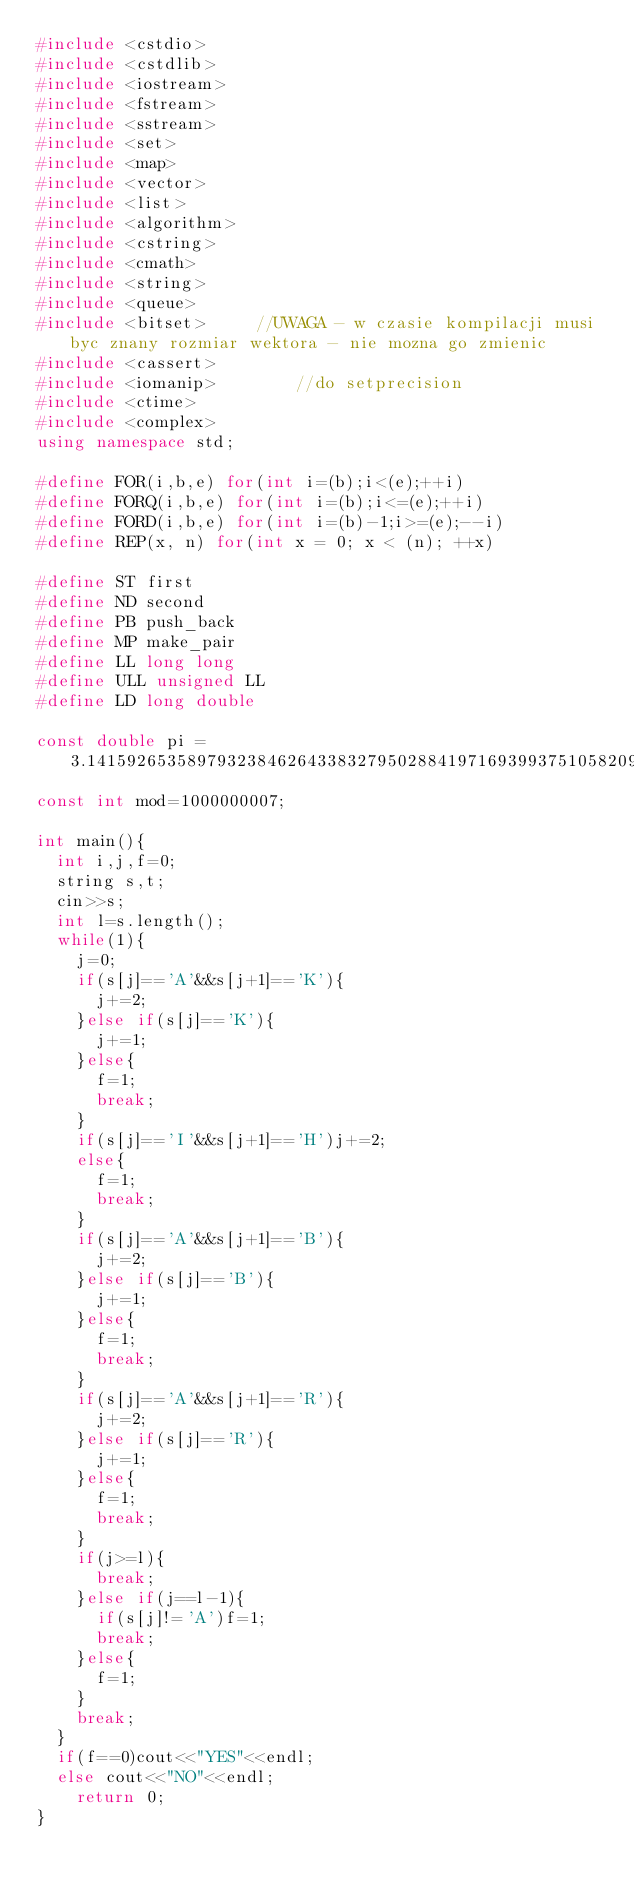Convert code to text. <code><loc_0><loc_0><loc_500><loc_500><_C++_>#include <cstdio>
#include <cstdlib>
#include <iostream>
#include <fstream>
#include <sstream>
#include <set>
#include <map>
#include <vector>
#include <list>
#include <algorithm>
#include <cstring>
#include <cmath>
#include <string>
#include <queue>
#include <bitset>     //UWAGA - w czasie kompilacji musi byc znany rozmiar wektora - nie mozna go zmienic
#include <cassert>
#include <iomanip>        //do setprecision
#include <ctime>
#include <complex>
using namespace std;

#define FOR(i,b,e) for(int i=(b);i<(e);++i)
#define FORQ(i,b,e) for(int i=(b);i<=(e);++i)
#define FORD(i,b,e) for(int i=(b)-1;i>=(e);--i)
#define REP(x, n) for(int x = 0; x < (n); ++x)

#define ST first
#define ND second
#define PB push_back
#define MP make_pair
#define LL long long
#define ULL unsigned LL
#define LD long double

const double pi = 3.141592653589793238462643383279502884197169399375105820974944592307816406286208998628034825342;
const int mod=1000000007;

int main(){
	int i,j,f=0;
	string s,t;
	cin>>s;
	int l=s.length();
	while(1){
		j=0;
		if(s[j]=='A'&&s[j+1]=='K'){
			j+=2;
		}else if(s[j]=='K'){
			j+=1;
		}else{
			f=1;
			break;
		}
		if(s[j]=='I'&&s[j+1]=='H')j+=2;
		else{
			f=1;
			break;
		}
		if(s[j]=='A'&&s[j+1]=='B'){
			j+=2;
		}else if(s[j]=='B'){
			j+=1;
		}else{
			f=1;
			break;
		}
		if(s[j]=='A'&&s[j+1]=='R'){
			j+=2;
		}else if(s[j]=='R'){
			j+=1;
		}else{
			f=1;
			break;
		}
		if(j>=l){
			break;
		}else if(j==l-1){
			if(s[j]!='A')f=1;
			break;
		}else{
			f=1;
		}
		break;
	}
	if(f==0)cout<<"YES"<<endl;
	else cout<<"NO"<<endl;
    return 0;
}
</code> 